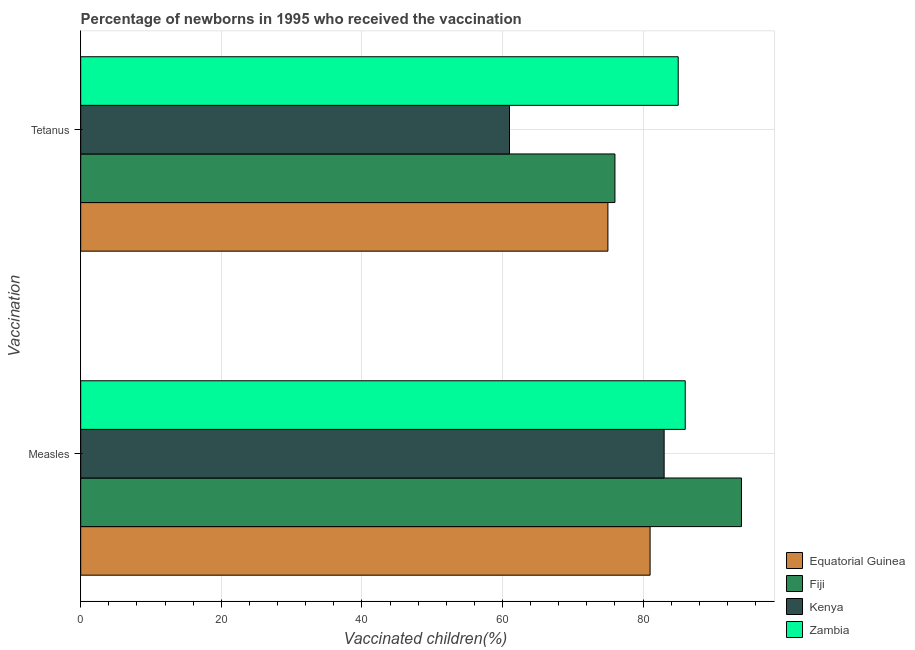How many groups of bars are there?
Provide a succinct answer. 2. Are the number of bars per tick equal to the number of legend labels?
Give a very brief answer. Yes. Are the number of bars on each tick of the Y-axis equal?
Make the answer very short. Yes. What is the label of the 2nd group of bars from the top?
Give a very brief answer. Measles. What is the percentage of newborns who received vaccination for measles in Equatorial Guinea?
Your answer should be compact. 81. Across all countries, what is the maximum percentage of newborns who received vaccination for measles?
Keep it short and to the point. 94. Across all countries, what is the minimum percentage of newborns who received vaccination for measles?
Your response must be concise. 81. In which country was the percentage of newborns who received vaccination for measles maximum?
Ensure brevity in your answer.  Fiji. In which country was the percentage of newborns who received vaccination for tetanus minimum?
Your answer should be very brief. Kenya. What is the total percentage of newborns who received vaccination for measles in the graph?
Make the answer very short. 344. What is the difference between the percentage of newborns who received vaccination for tetanus in Kenya and that in Zambia?
Provide a succinct answer. -24. What is the difference between the percentage of newborns who received vaccination for tetanus in Fiji and the percentage of newborns who received vaccination for measles in Kenya?
Your response must be concise. -7. What is the average percentage of newborns who received vaccination for measles per country?
Provide a succinct answer. 86. What is the difference between the percentage of newborns who received vaccination for tetanus and percentage of newborns who received vaccination for measles in Zambia?
Your answer should be very brief. -1. In how many countries, is the percentage of newborns who received vaccination for tetanus greater than 48 %?
Provide a short and direct response. 4. What is the ratio of the percentage of newborns who received vaccination for tetanus in Kenya to that in Zambia?
Keep it short and to the point. 0.72. What does the 3rd bar from the top in Measles represents?
Your response must be concise. Fiji. What does the 1st bar from the bottom in Measles represents?
Ensure brevity in your answer.  Equatorial Guinea. What is the difference between two consecutive major ticks on the X-axis?
Keep it short and to the point. 20. How many legend labels are there?
Your answer should be very brief. 4. What is the title of the graph?
Keep it short and to the point. Percentage of newborns in 1995 who received the vaccination. What is the label or title of the X-axis?
Give a very brief answer. Vaccinated children(%)
. What is the label or title of the Y-axis?
Your answer should be very brief. Vaccination. What is the Vaccinated children(%)
 of Equatorial Guinea in Measles?
Your answer should be very brief. 81. What is the Vaccinated children(%)
 in Fiji in Measles?
Ensure brevity in your answer.  94. What is the Vaccinated children(%)
 in Zambia in Measles?
Offer a very short reply. 86. What is the Vaccinated children(%)
 of Fiji in Tetanus?
Provide a succinct answer. 76. What is the Vaccinated children(%)
 of Kenya in Tetanus?
Make the answer very short. 61. Across all Vaccination, what is the maximum Vaccinated children(%)
 of Equatorial Guinea?
Give a very brief answer. 81. Across all Vaccination, what is the maximum Vaccinated children(%)
 in Fiji?
Offer a very short reply. 94. Across all Vaccination, what is the minimum Vaccinated children(%)
 in Equatorial Guinea?
Offer a very short reply. 75. Across all Vaccination, what is the minimum Vaccinated children(%)
 in Zambia?
Provide a short and direct response. 85. What is the total Vaccinated children(%)
 in Equatorial Guinea in the graph?
Ensure brevity in your answer.  156. What is the total Vaccinated children(%)
 of Fiji in the graph?
Your answer should be compact. 170. What is the total Vaccinated children(%)
 of Kenya in the graph?
Give a very brief answer. 144. What is the total Vaccinated children(%)
 of Zambia in the graph?
Provide a succinct answer. 171. What is the difference between the Vaccinated children(%)
 in Equatorial Guinea in Measles and that in Tetanus?
Offer a very short reply. 6. What is the difference between the Vaccinated children(%)
 in Fiji in Measles and that in Tetanus?
Keep it short and to the point. 18. What is the difference between the Vaccinated children(%)
 of Zambia in Measles and that in Tetanus?
Provide a short and direct response. 1. What is the difference between the Vaccinated children(%)
 of Equatorial Guinea in Measles and the Vaccinated children(%)
 of Fiji in Tetanus?
Offer a terse response. 5. What is the difference between the Vaccinated children(%)
 in Equatorial Guinea in Measles and the Vaccinated children(%)
 in Kenya in Tetanus?
Provide a short and direct response. 20. What is the difference between the Vaccinated children(%)
 in Equatorial Guinea in Measles and the Vaccinated children(%)
 in Zambia in Tetanus?
Give a very brief answer. -4. What is the difference between the Vaccinated children(%)
 in Kenya in Measles and the Vaccinated children(%)
 in Zambia in Tetanus?
Provide a short and direct response. -2. What is the average Vaccinated children(%)
 of Fiji per Vaccination?
Offer a terse response. 85. What is the average Vaccinated children(%)
 in Kenya per Vaccination?
Provide a short and direct response. 72. What is the average Vaccinated children(%)
 in Zambia per Vaccination?
Your answer should be very brief. 85.5. What is the difference between the Vaccinated children(%)
 in Equatorial Guinea and Vaccinated children(%)
 in Fiji in Measles?
Make the answer very short. -13. What is the difference between the Vaccinated children(%)
 in Equatorial Guinea and Vaccinated children(%)
 in Kenya in Measles?
Your response must be concise. -2. What is the difference between the Vaccinated children(%)
 of Kenya and Vaccinated children(%)
 of Zambia in Measles?
Your answer should be very brief. -3. What is the difference between the Vaccinated children(%)
 in Equatorial Guinea and Vaccinated children(%)
 in Fiji in Tetanus?
Ensure brevity in your answer.  -1. What is the difference between the Vaccinated children(%)
 in Equatorial Guinea and Vaccinated children(%)
 in Zambia in Tetanus?
Your answer should be very brief. -10. What is the difference between the Vaccinated children(%)
 in Fiji and Vaccinated children(%)
 in Kenya in Tetanus?
Give a very brief answer. 15. What is the difference between the Vaccinated children(%)
 in Fiji and Vaccinated children(%)
 in Zambia in Tetanus?
Give a very brief answer. -9. What is the ratio of the Vaccinated children(%)
 in Fiji in Measles to that in Tetanus?
Your answer should be very brief. 1.24. What is the ratio of the Vaccinated children(%)
 in Kenya in Measles to that in Tetanus?
Provide a short and direct response. 1.36. What is the ratio of the Vaccinated children(%)
 in Zambia in Measles to that in Tetanus?
Your answer should be compact. 1.01. What is the difference between the highest and the second highest Vaccinated children(%)
 of Equatorial Guinea?
Give a very brief answer. 6. What is the difference between the highest and the lowest Vaccinated children(%)
 of Equatorial Guinea?
Your answer should be very brief. 6. What is the difference between the highest and the lowest Vaccinated children(%)
 in Zambia?
Your response must be concise. 1. 